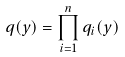<formula> <loc_0><loc_0><loc_500><loc_500>q ( y ) = \prod _ { i = 1 } ^ { n } q _ { i } ( y )</formula> 